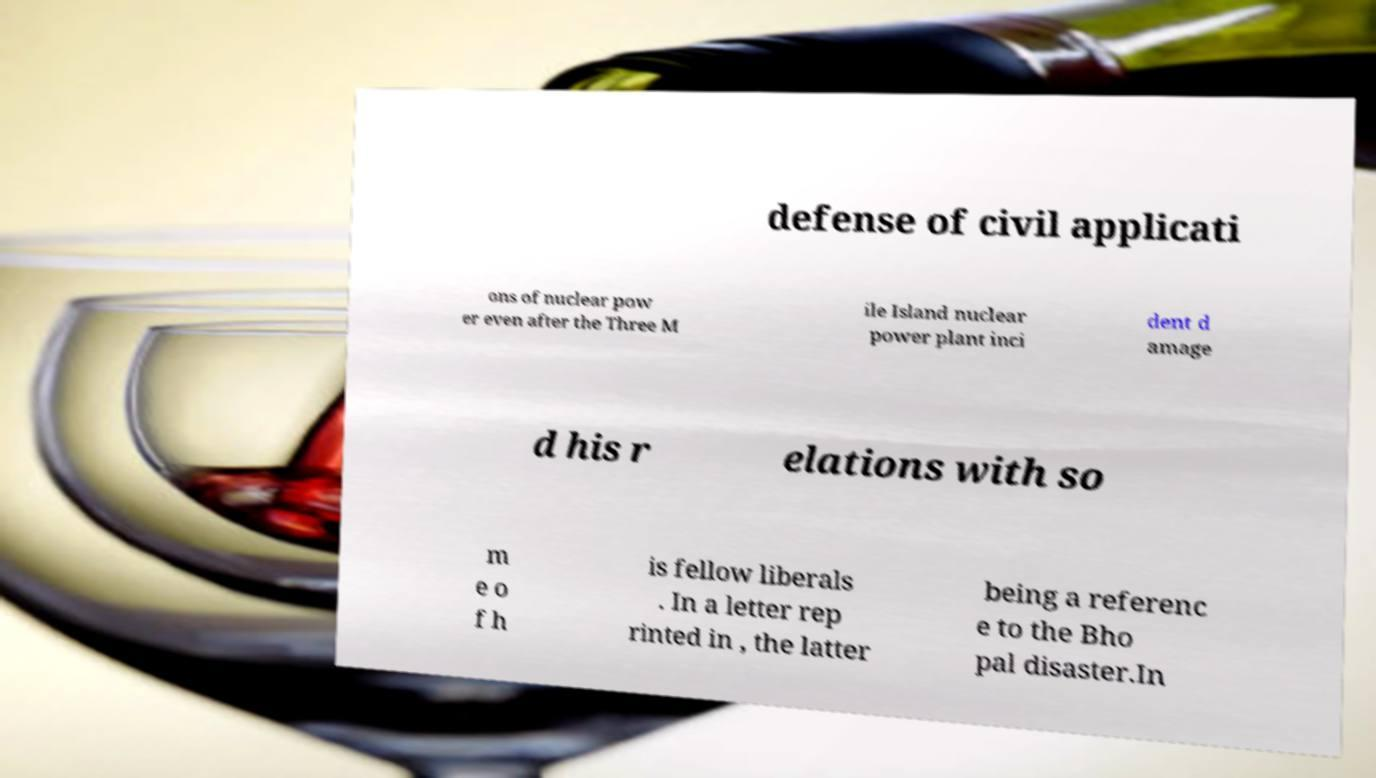For documentation purposes, I need the text within this image transcribed. Could you provide that? defense of civil applicati ons of nuclear pow er even after the Three M ile Island nuclear power plant inci dent d amage d his r elations with so m e o f h is fellow liberals . In a letter rep rinted in , the latter being a referenc e to the Bho pal disaster.In 